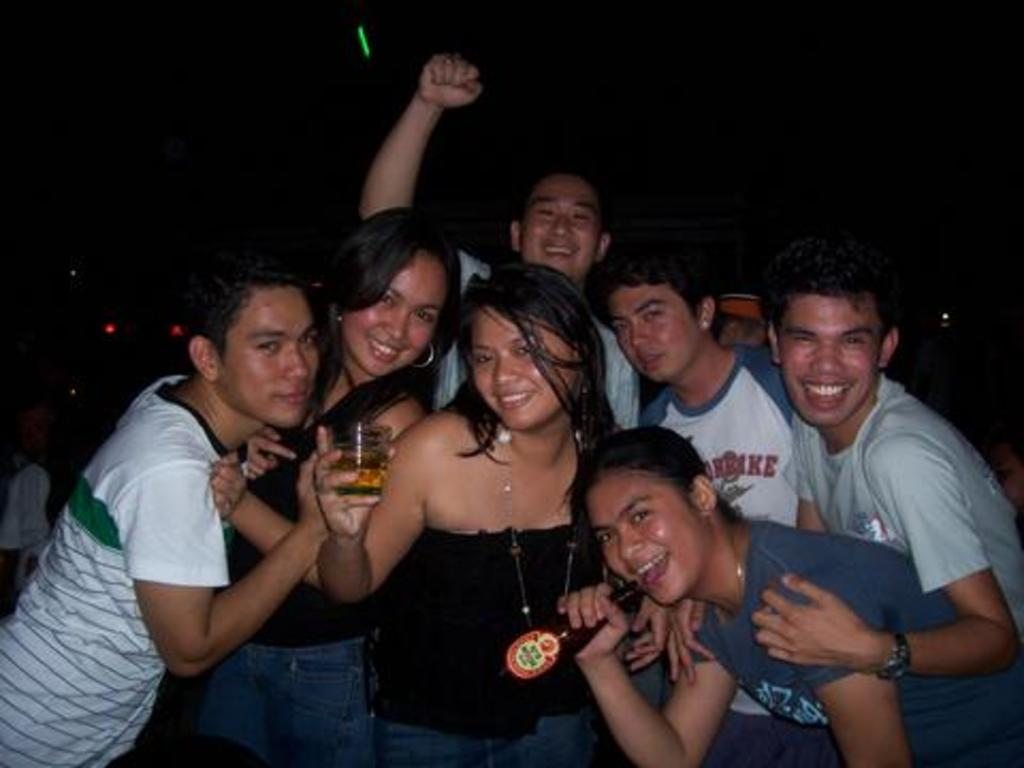What is the main subject of the image? The main subject of the image is a group of people. Can you describe what one of the people is holding? Yes, a woman is holding a glass with beer. Are there any other objects being held by the people in the image? Yes, another person is holding a bottle. What type of low is present in the image? There is no mention of a low in the image, as the focus is on the group of people and the objects they are holding. 